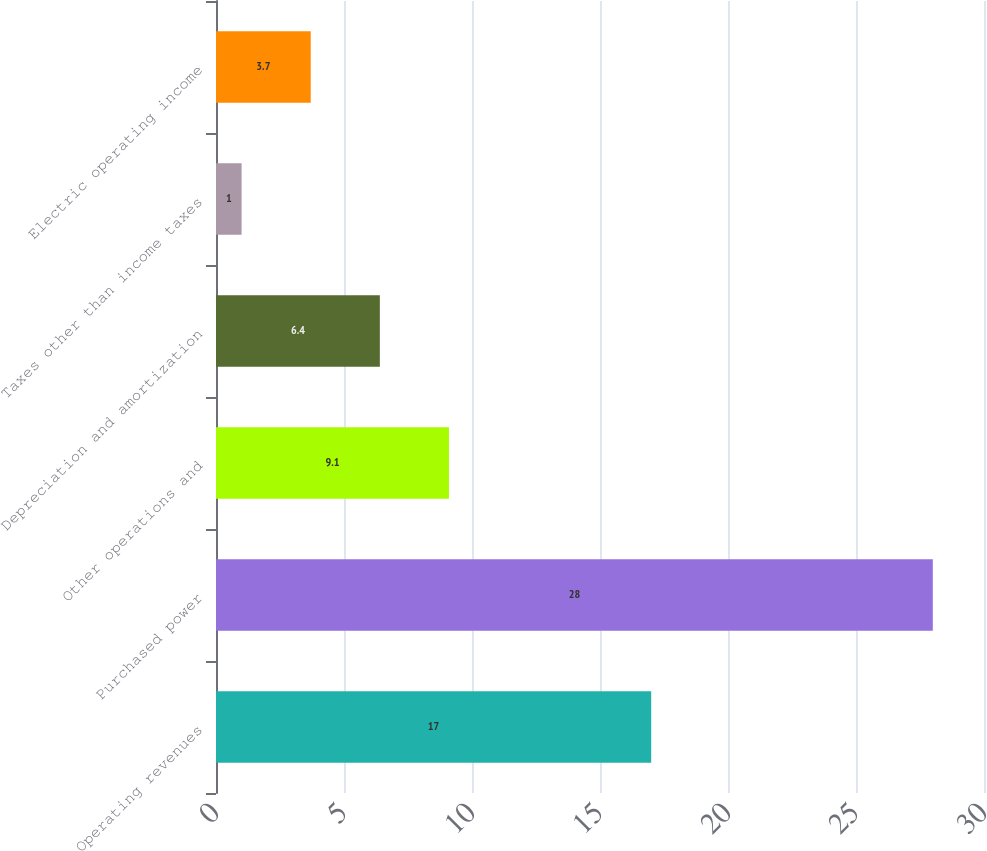Convert chart to OTSL. <chart><loc_0><loc_0><loc_500><loc_500><bar_chart><fcel>Operating revenues<fcel>Purchased power<fcel>Other operations and<fcel>Depreciation and amortization<fcel>Taxes other than income taxes<fcel>Electric operating income<nl><fcel>17<fcel>28<fcel>9.1<fcel>6.4<fcel>1<fcel>3.7<nl></chart> 